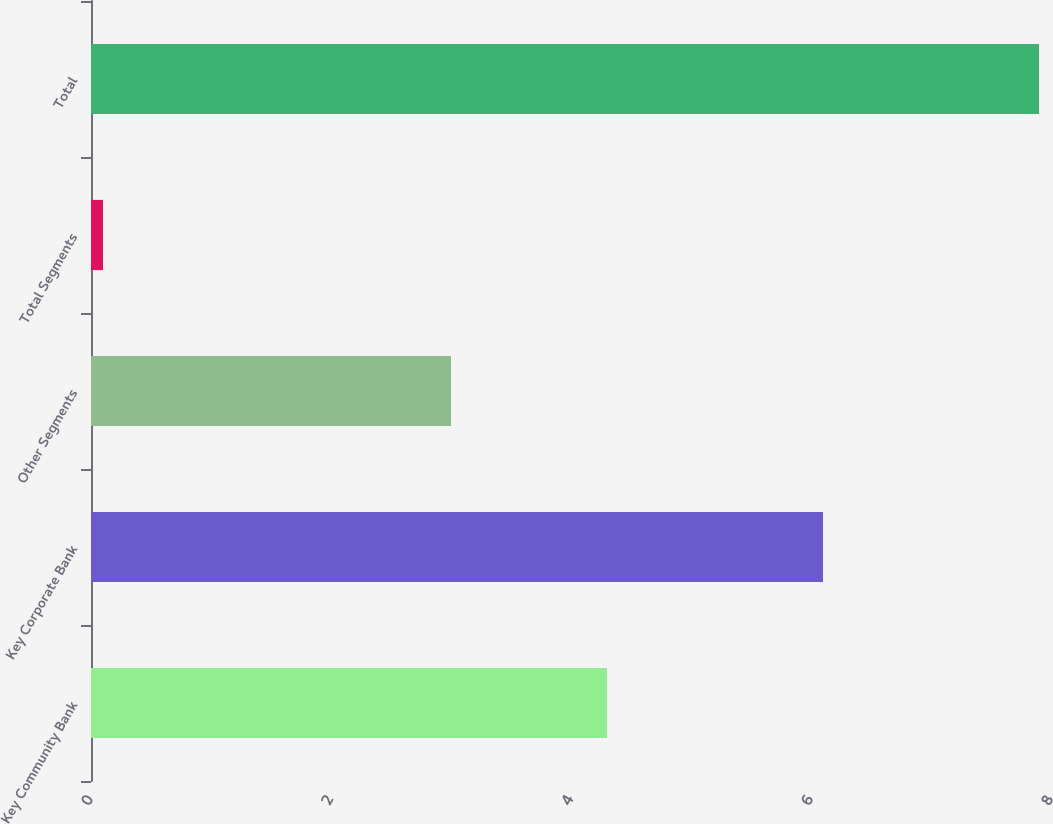Convert chart. <chart><loc_0><loc_0><loc_500><loc_500><bar_chart><fcel>Key Community Bank<fcel>Key Corporate Bank<fcel>Other Segments<fcel>Total Segments<fcel>Total<nl><fcel>4.3<fcel>6.1<fcel>3<fcel>0.1<fcel>7.9<nl></chart> 